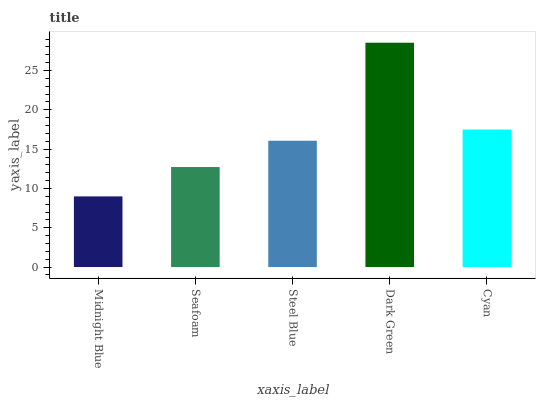Is Midnight Blue the minimum?
Answer yes or no. Yes. Is Dark Green the maximum?
Answer yes or no. Yes. Is Seafoam the minimum?
Answer yes or no. No. Is Seafoam the maximum?
Answer yes or no. No. Is Seafoam greater than Midnight Blue?
Answer yes or no. Yes. Is Midnight Blue less than Seafoam?
Answer yes or no. Yes. Is Midnight Blue greater than Seafoam?
Answer yes or no. No. Is Seafoam less than Midnight Blue?
Answer yes or no. No. Is Steel Blue the high median?
Answer yes or no. Yes. Is Steel Blue the low median?
Answer yes or no. Yes. Is Midnight Blue the high median?
Answer yes or no. No. Is Midnight Blue the low median?
Answer yes or no. No. 